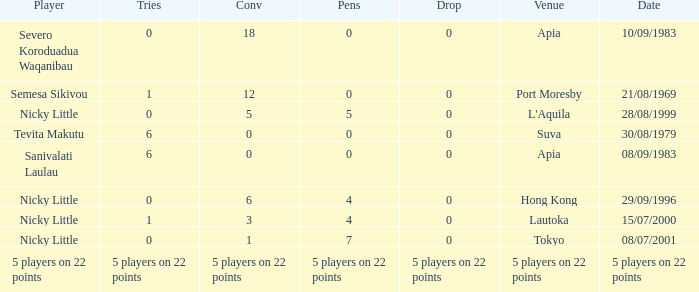How many drops did Nicky Little have in Hong Kong? 0.0. 